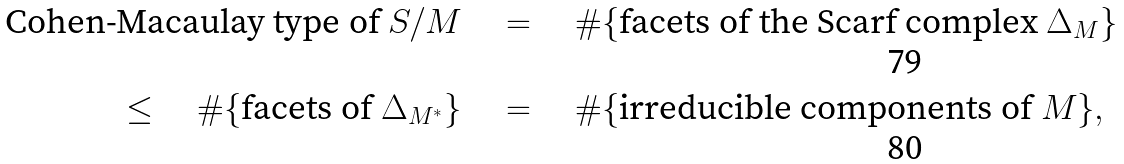Convert formula to latex. <formula><loc_0><loc_0><loc_500><loc_500>\text {Cohen-Macaulay type of $S/M$} & \quad = \quad \# \{ \text {facets of the Scarf complex $\Delta_{M}$} \} \\ \leq \quad \# \{ \text {facets of $\Delta_{M^{*}}$} \} & \quad = \quad \# \{ \text {irreducible components of $M$} \} ,</formula> 